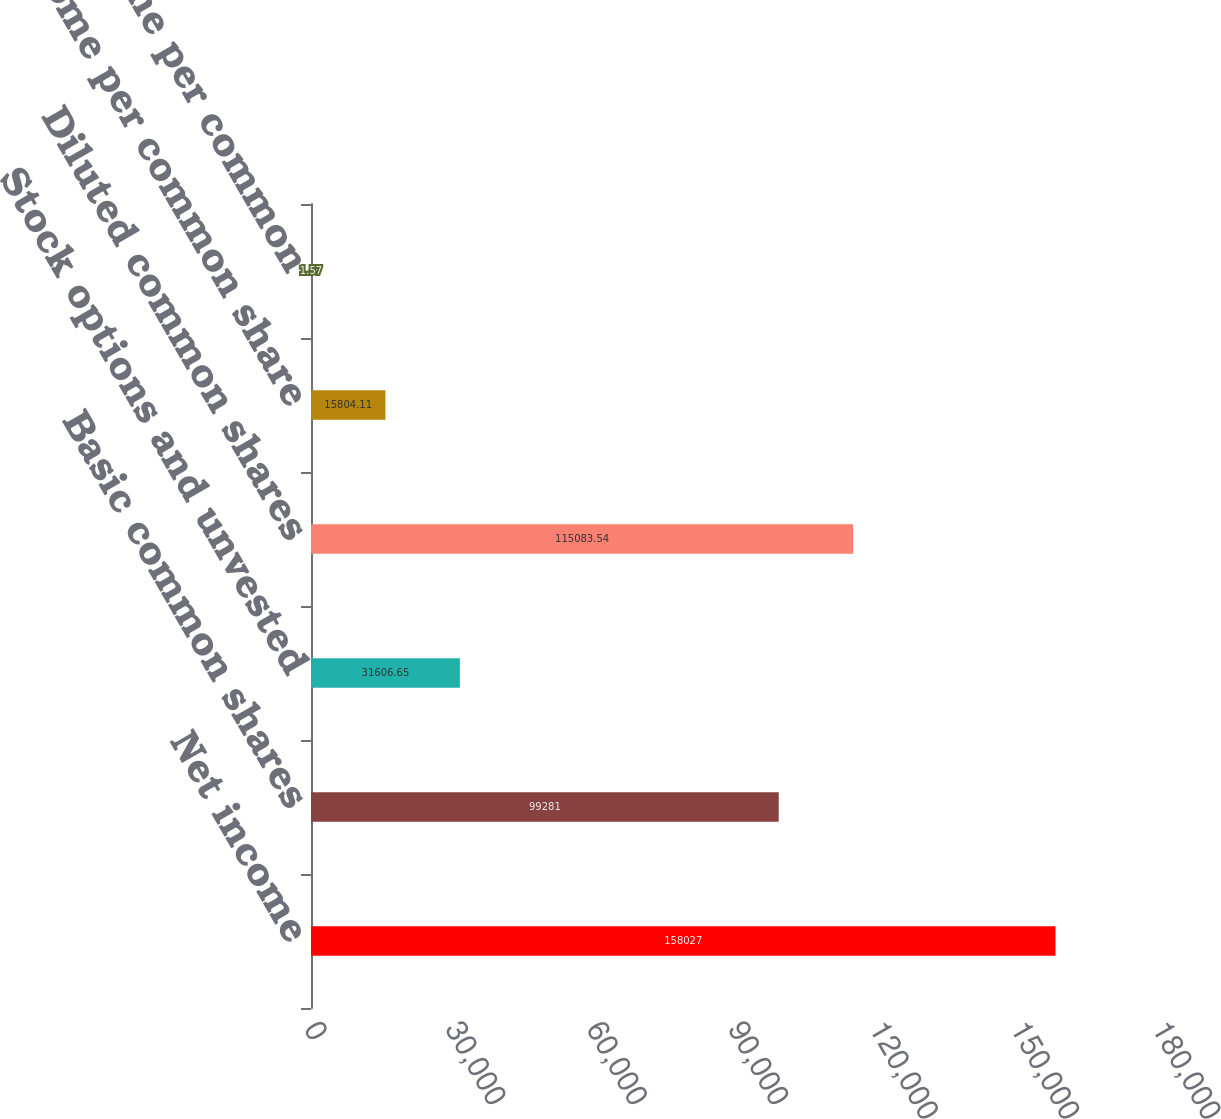Convert chart to OTSL. <chart><loc_0><loc_0><loc_500><loc_500><bar_chart><fcel>Net income<fcel>Basic common shares<fcel>Stock options and unvested<fcel>Diluted common shares<fcel>Basic income per common share<fcel>Diluted income per common<nl><fcel>158027<fcel>99281<fcel>31606.7<fcel>115084<fcel>15804.1<fcel>1.57<nl></chart> 